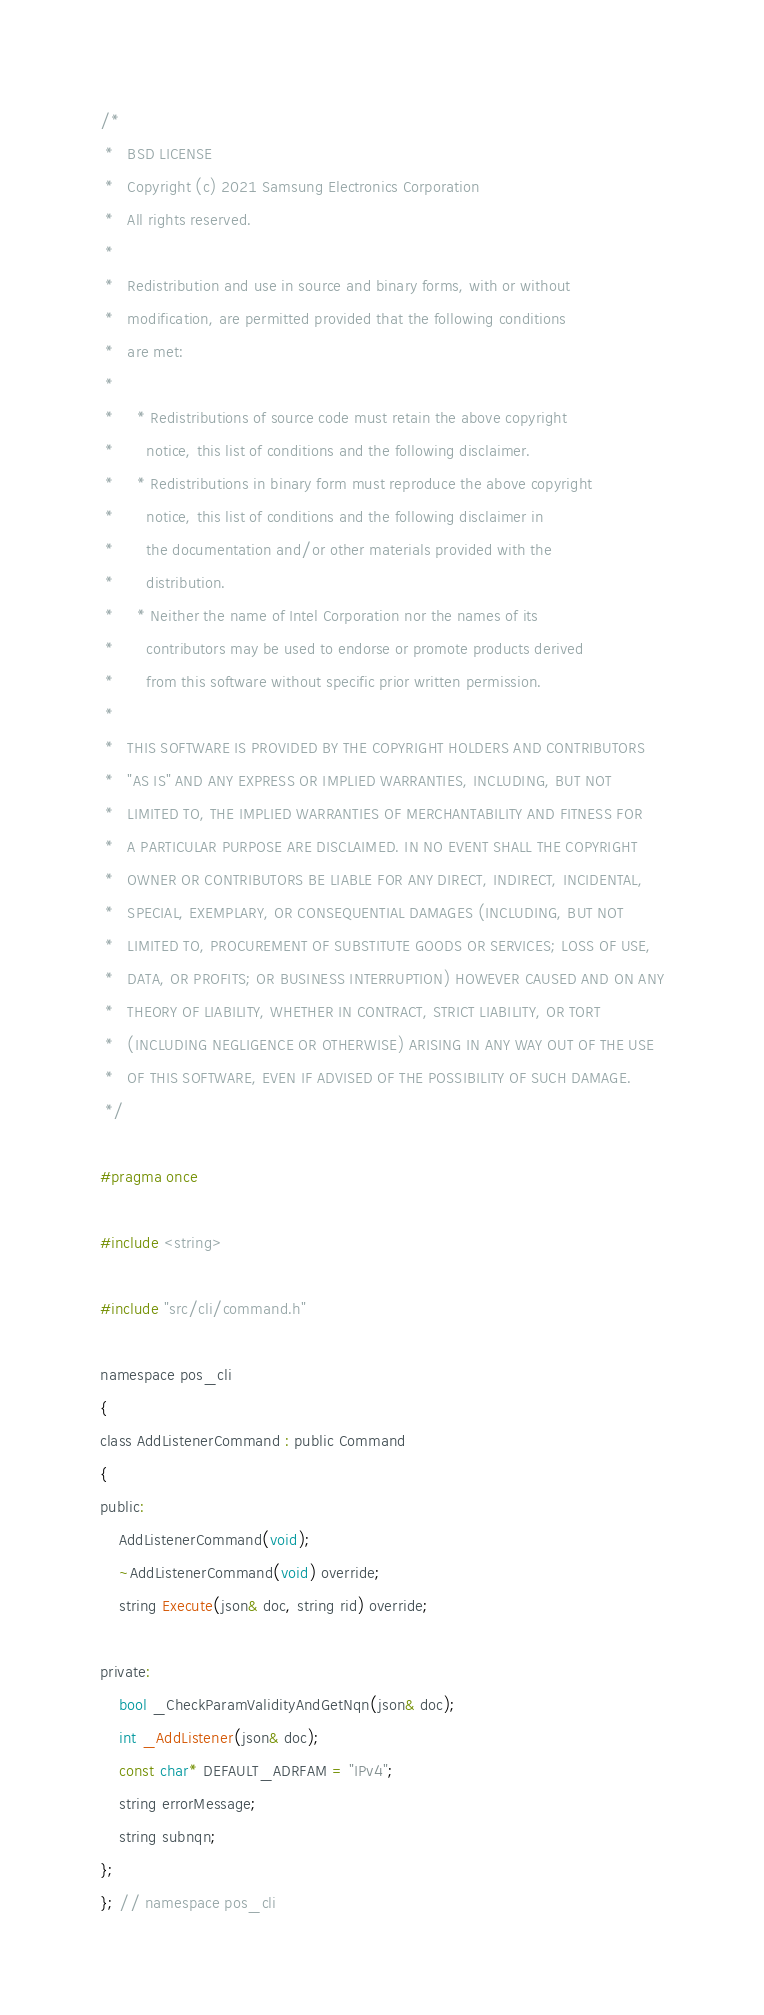<code> <loc_0><loc_0><loc_500><loc_500><_C_>/*
 *   BSD LICENSE
 *   Copyright (c) 2021 Samsung Electronics Corporation
 *   All rights reserved.
 *
 *   Redistribution and use in source and binary forms, with or without
 *   modification, are permitted provided that the following conditions
 *   are met:
 *
 *     * Redistributions of source code must retain the above copyright
 *       notice, this list of conditions and the following disclaimer.
 *     * Redistributions in binary form must reproduce the above copyright
 *       notice, this list of conditions and the following disclaimer in
 *       the documentation and/or other materials provided with the
 *       distribution.
 *     * Neither the name of Intel Corporation nor the names of its
 *       contributors may be used to endorse or promote products derived
 *       from this software without specific prior written permission.
 *
 *   THIS SOFTWARE IS PROVIDED BY THE COPYRIGHT HOLDERS AND CONTRIBUTORS
 *   "AS IS" AND ANY EXPRESS OR IMPLIED WARRANTIES, INCLUDING, BUT NOT
 *   LIMITED TO, THE IMPLIED WARRANTIES OF MERCHANTABILITY AND FITNESS FOR
 *   A PARTICULAR PURPOSE ARE DISCLAIMED. IN NO EVENT SHALL THE COPYRIGHT
 *   OWNER OR CONTRIBUTORS BE LIABLE FOR ANY DIRECT, INDIRECT, INCIDENTAL,
 *   SPECIAL, EXEMPLARY, OR CONSEQUENTIAL DAMAGES (INCLUDING, BUT NOT
 *   LIMITED TO, PROCUREMENT OF SUBSTITUTE GOODS OR SERVICES; LOSS OF USE,
 *   DATA, OR PROFITS; OR BUSINESS INTERRUPTION) HOWEVER CAUSED AND ON ANY
 *   THEORY OF LIABILITY, WHETHER IN CONTRACT, STRICT LIABILITY, OR TORT
 *   (INCLUDING NEGLIGENCE OR OTHERWISE) ARISING IN ANY WAY OUT OF THE USE
 *   OF THIS SOFTWARE, EVEN IF ADVISED OF THE POSSIBILITY OF SUCH DAMAGE.
 */

#pragma once

#include <string>

#include "src/cli/command.h"

namespace pos_cli
{
class AddListenerCommand : public Command
{
public:
    AddListenerCommand(void);
    ~AddListenerCommand(void) override;
    string Execute(json& doc, string rid) override;

private:
    bool _CheckParamValidityAndGetNqn(json& doc);
    int _AddListener(json& doc);
    const char* DEFAULT_ADRFAM = "IPv4";
    string errorMessage;
    string subnqn;
};
}; // namespace pos_cli
</code> 